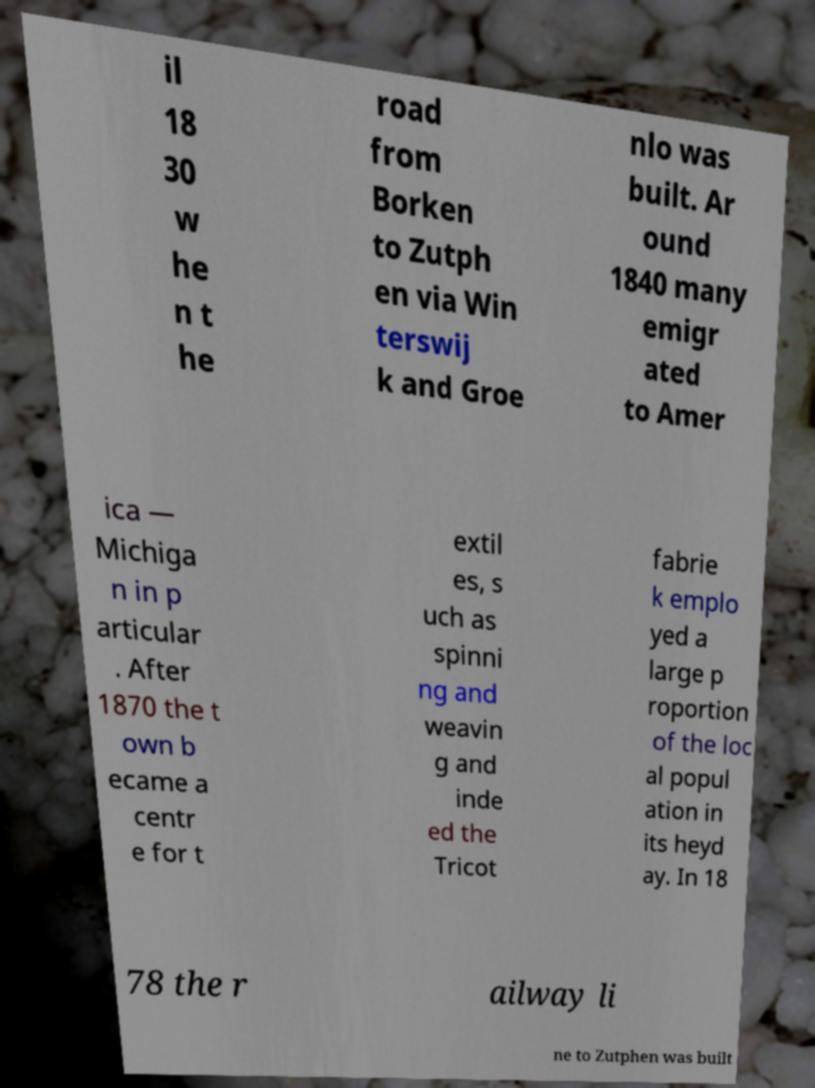Could you extract and type out the text from this image? il 18 30 w he n t he road from Borken to Zutph en via Win terswij k and Groe nlo was built. Ar ound 1840 many emigr ated to Amer ica — Michiga n in p articular . After 1870 the t own b ecame a centr e for t extil es, s uch as spinni ng and weavin g and inde ed the Tricot fabrie k emplo yed a large p roportion of the loc al popul ation in its heyd ay. In 18 78 the r ailway li ne to Zutphen was built 